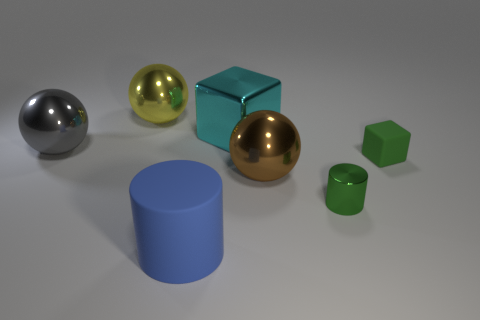Add 1 large brown matte things. How many objects exist? 8 Subtract all balls. How many objects are left? 4 Subtract 1 cyan blocks. How many objects are left? 6 Subtract all big green metallic balls. Subtract all rubber cubes. How many objects are left? 6 Add 2 metallic cylinders. How many metallic cylinders are left? 3 Add 1 big metallic objects. How many big metallic objects exist? 5 